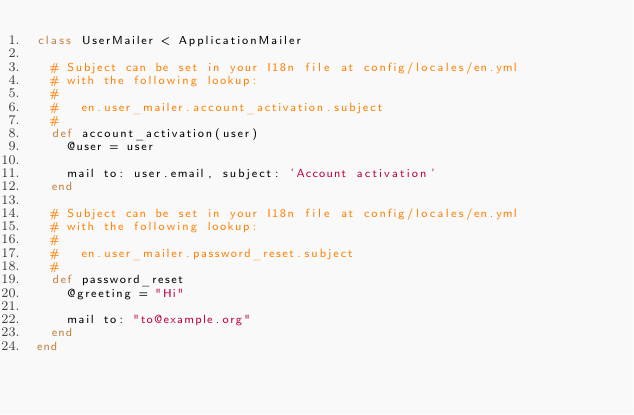<code> <loc_0><loc_0><loc_500><loc_500><_Ruby_>class UserMailer < ApplicationMailer

  # Subject can be set in your I18n file at config/locales/en.yml
  # with the following lookup:
  #
  #   en.user_mailer.account_activation.subject
  #
  def account_activation(user)
    @user = user

    mail to: user.email, subject: 'Account activation'
  end

  # Subject can be set in your I18n file at config/locales/en.yml
  # with the following lookup:
  #
  #   en.user_mailer.password_reset.subject
  #
  def password_reset
    @greeting = "Hi"

    mail to: "to@example.org"
  end
end
</code> 